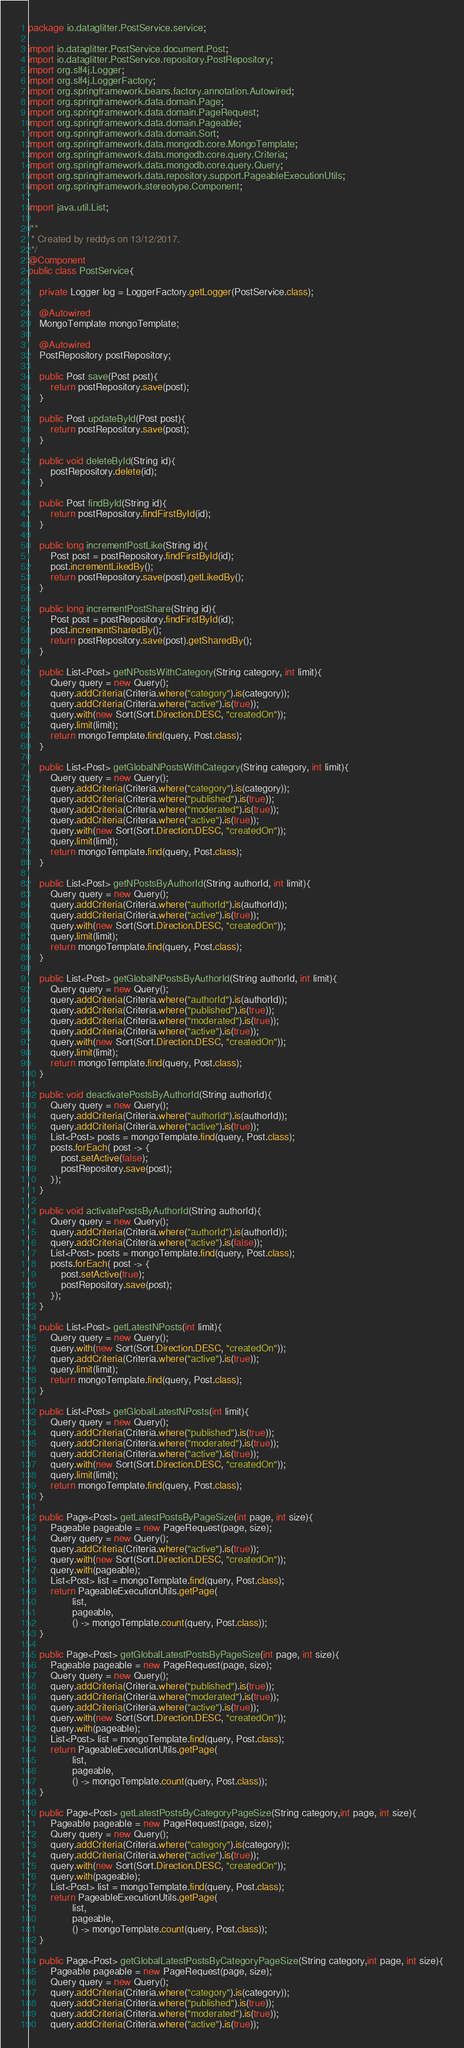<code> <loc_0><loc_0><loc_500><loc_500><_Java_>package io.dataglitter.PostService.service;

import io.dataglitter.PostService.document.Post;
import io.dataglitter.PostService.repository.PostRepository;
import org.slf4j.Logger;
import org.slf4j.LoggerFactory;
import org.springframework.beans.factory.annotation.Autowired;
import org.springframework.data.domain.Page;
import org.springframework.data.domain.PageRequest;
import org.springframework.data.domain.Pageable;
import org.springframework.data.domain.Sort;
import org.springframework.data.mongodb.core.MongoTemplate;
import org.springframework.data.mongodb.core.query.Criteria;
import org.springframework.data.mongodb.core.query.Query;
import org.springframework.data.repository.support.PageableExecutionUtils;
import org.springframework.stereotype.Component;

import java.util.List;

/**
 * Created by reddys on 13/12/2017.
 */
@Component
public class PostService{

    private Logger log = LoggerFactory.getLogger(PostService.class);

    @Autowired
    MongoTemplate mongoTemplate;

    @Autowired
    PostRepository postRepository;

    public Post save(Post post){
        return postRepository.save(post);
    }

    public Post updateById(Post post){
        return postRepository.save(post);
    }

    public void deleteById(String id){
        postRepository.delete(id);
    }

    public Post findById(String id){
        return postRepository.findFirstById(id);
    }

    public long incrementPostLike(String id){
        Post post = postRepository.findFirstById(id);
        post.incrementLikedBy();
        return postRepository.save(post).getLikedBy();
    }

    public long incrementPostShare(String id){
        Post post = postRepository.findFirstById(id);
        post.incrementSharedBy();
        return postRepository.save(post).getSharedBy();
    }

    public List<Post> getNPostsWithCategory(String category, int limit){
        Query query = new Query();
        query.addCriteria(Criteria.where("category").is(category));
        query.addCriteria(Criteria.where("active").is(true));
        query.with(new Sort(Sort.Direction.DESC, "createdOn"));
        query.limit(limit);
        return mongoTemplate.find(query, Post.class);
    }

    public List<Post> getGlobalNPostsWithCategory(String category, int limit){
        Query query = new Query();
        query.addCriteria(Criteria.where("category").is(category));
        query.addCriteria(Criteria.where("published").is(true));
        query.addCriteria(Criteria.where("moderated").is(true));
        query.addCriteria(Criteria.where("active").is(true));
        query.with(new Sort(Sort.Direction.DESC, "createdOn"));
        query.limit(limit);
        return mongoTemplate.find(query, Post.class);
    }

    public List<Post> getNPostsByAuthorId(String authorId, int limit){
        Query query = new Query();
        query.addCriteria(Criteria.where("authorId").is(authorId));
        query.addCriteria(Criteria.where("active").is(true));
        query.with(new Sort(Sort.Direction.DESC, "createdOn"));
        query.limit(limit);
        return mongoTemplate.find(query, Post.class);
    }

    public List<Post> getGlobalNPostsByAuthorId(String authorId, int limit){
        Query query = new Query();
        query.addCriteria(Criteria.where("authorId").is(authorId));
        query.addCriteria(Criteria.where("published").is(true));
        query.addCriteria(Criteria.where("moderated").is(true));
        query.addCriteria(Criteria.where("active").is(true));
        query.with(new Sort(Sort.Direction.DESC, "createdOn"));
        query.limit(limit);
        return mongoTemplate.find(query, Post.class);
    }

    public void deactivatePostsByAuthorId(String authorId){
        Query query = new Query();
        query.addCriteria(Criteria.where("authorId").is(authorId));
        query.addCriteria(Criteria.where("active").is(true));
        List<Post> posts = mongoTemplate.find(query, Post.class);
        posts.forEach( post -> {
            post.setActive(false);
            postRepository.save(post);
        });
    }

    public void activatePostsByAuthorId(String authorId){
        Query query = new Query();
        query.addCriteria(Criteria.where("authorId").is(authorId));
        query.addCriteria(Criteria.where("active").is(false));
        List<Post> posts = mongoTemplate.find(query, Post.class);
        posts.forEach( post -> {
            post.setActive(true);
            postRepository.save(post);
        });
    }

    public List<Post> getLatestNPosts(int limit){
        Query query = new Query();
        query.with(new Sort(Sort.Direction.DESC, "createdOn"));
        query.addCriteria(Criteria.where("active").is(true));
        query.limit(limit);
        return mongoTemplate.find(query, Post.class);
    }

    public List<Post> getGlobalLatestNPosts(int limit){
        Query query = new Query();
        query.addCriteria(Criteria.where("published").is(true));
        query.addCriteria(Criteria.where("moderated").is(true));
        query.addCriteria(Criteria.where("active").is(true));
        query.with(new Sort(Sort.Direction.DESC, "createdOn"));
        query.limit(limit);
        return mongoTemplate.find(query, Post.class);
    }

    public Page<Post> getLatestPostsByPageSize(int page, int size){
        Pageable pageable = new PageRequest(page, size);
        Query query = new Query();
        query.addCriteria(Criteria.where("active").is(true));
        query.with(new Sort(Sort.Direction.DESC, "createdOn"));
        query.with(pageable);
        List<Post> list = mongoTemplate.find(query, Post.class);
        return PageableExecutionUtils.getPage(
                list,
                pageable,
                () -> mongoTemplate.count(query, Post.class));
    }

    public Page<Post> getGlobalLatestPostsByPageSize(int page, int size){
        Pageable pageable = new PageRequest(page, size);
        Query query = new Query();
        query.addCriteria(Criteria.where("published").is(true));
        query.addCriteria(Criteria.where("moderated").is(true));
        query.addCriteria(Criteria.where("active").is(true));
        query.with(new Sort(Sort.Direction.DESC, "createdOn"));
        query.with(pageable);
        List<Post> list = mongoTemplate.find(query, Post.class);
        return PageableExecutionUtils.getPage(
                list,
                pageable,
                () -> mongoTemplate.count(query, Post.class));
    }

    public Page<Post> getLatestPostsByCategoryPageSize(String category,int page, int size){
        Pageable pageable = new PageRequest(page, size);
        Query query = new Query();
        query.addCriteria(Criteria.where("category").is(category));
        query.addCriteria(Criteria.where("active").is(true));
        query.with(new Sort(Sort.Direction.DESC, "createdOn"));
        query.with(pageable);
        List<Post> list = mongoTemplate.find(query, Post.class);
        return PageableExecutionUtils.getPage(
                list,
                pageable,
                () -> mongoTemplate.count(query, Post.class));
    }

    public Page<Post> getGlobalLatestPostsByCategoryPageSize(String category,int page, int size){
        Pageable pageable = new PageRequest(page, size);
        Query query = new Query();
        query.addCriteria(Criteria.where("category").is(category));
        query.addCriteria(Criteria.where("published").is(true));
        query.addCriteria(Criteria.where("moderated").is(true));
        query.addCriteria(Criteria.where("active").is(true));</code> 